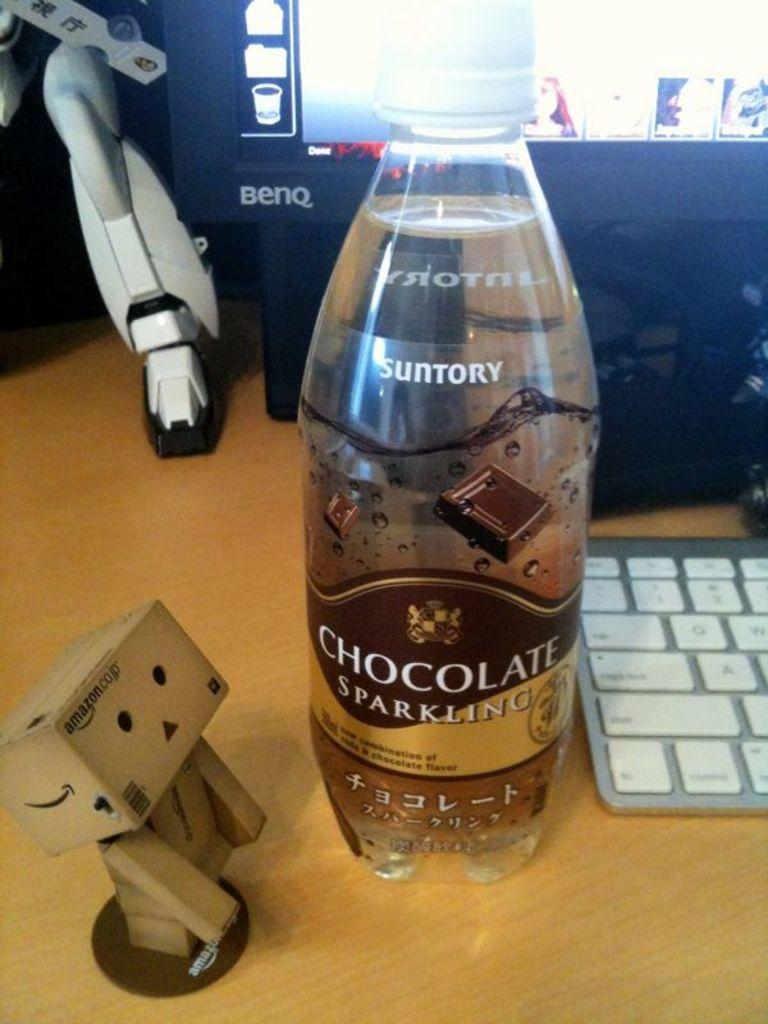What flavour is this sparkling water?
Offer a terse response. Chocolate. Who makes this water?
Make the answer very short. Suntory. 